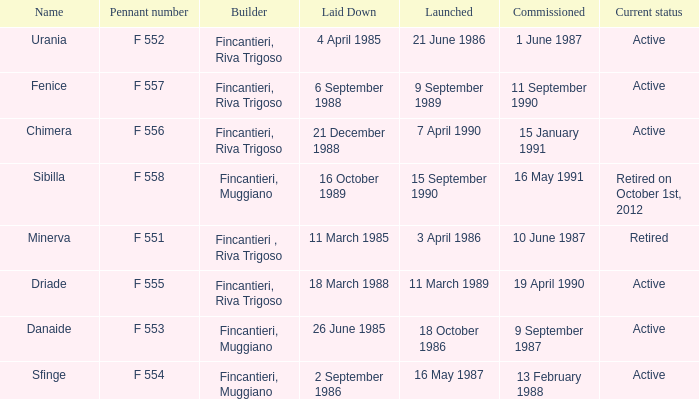What is the name of the builder who launched in danaide 18 October 1986. 